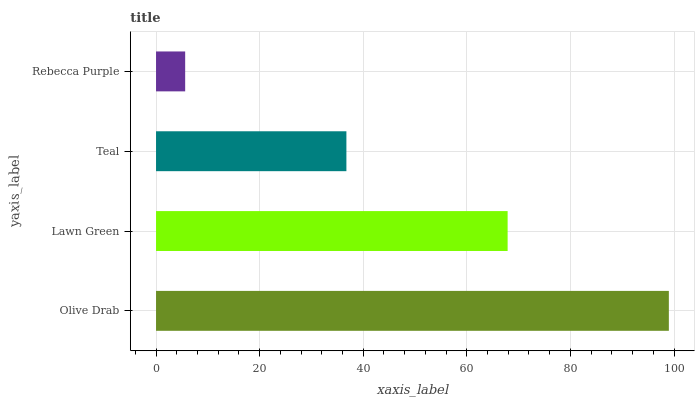Is Rebecca Purple the minimum?
Answer yes or no. Yes. Is Olive Drab the maximum?
Answer yes or no. Yes. Is Lawn Green the minimum?
Answer yes or no. No. Is Lawn Green the maximum?
Answer yes or no. No. Is Olive Drab greater than Lawn Green?
Answer yes or no. Yes. Is Lawn Green less than Olive Drab?
Answer yes or no. Yes. Is Lawn Green greater than Olive Drab?
Answer yes or no. No. Is Olive Drab less than Lawn Green?
Answer yes or no. No. Is Lawn Green the high median?
Answer yes or no. Yes. Is Teal the low median?
Answer yes or no. Yes. Is Rebecca Purple the high median?
Answer yes or no. No. Is Lawn Green the low median?
Answer yes or no. No. 